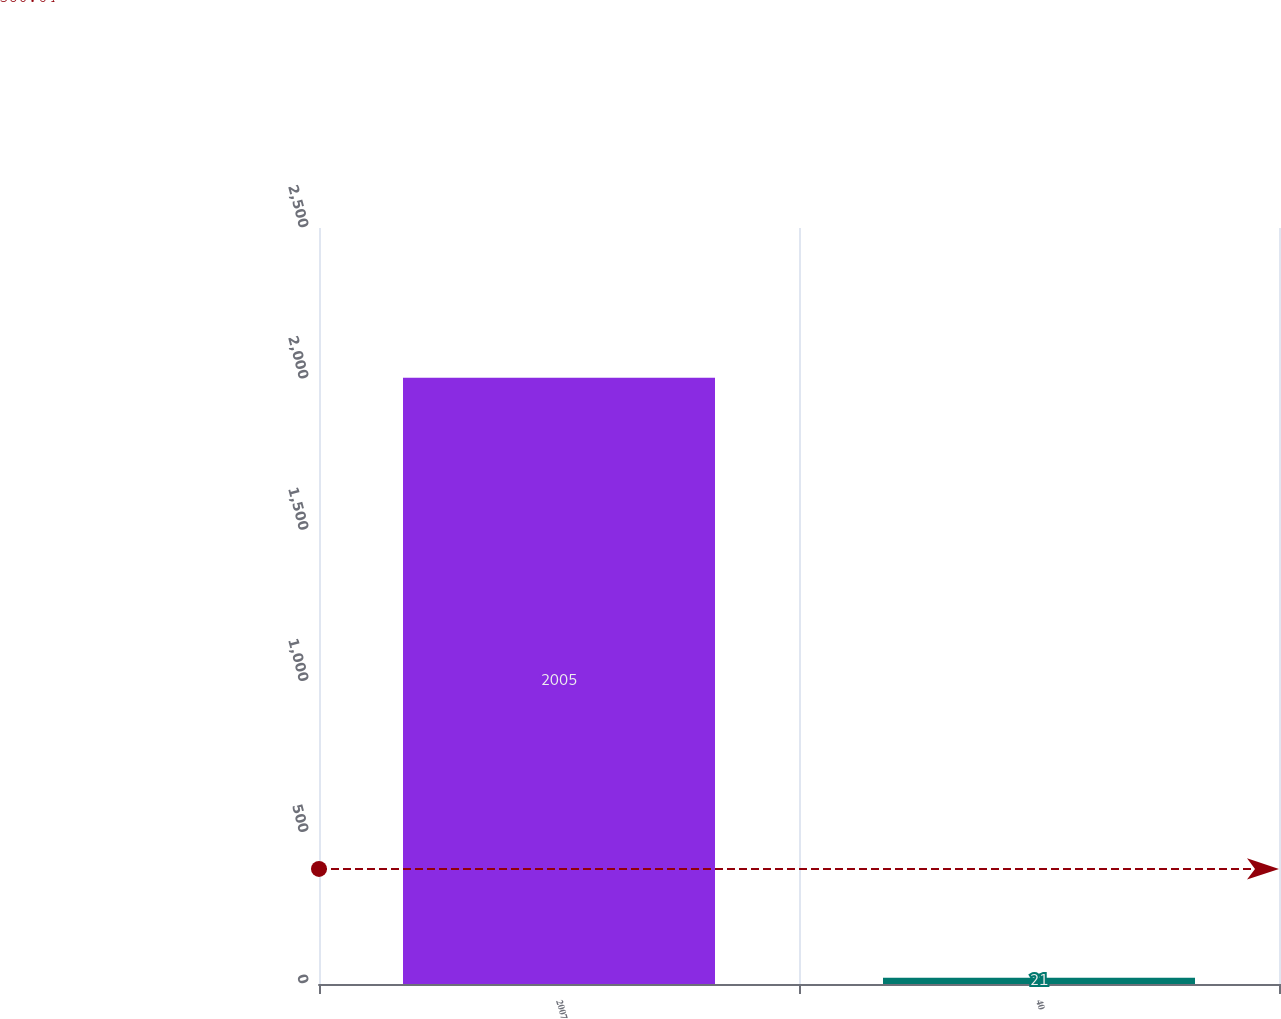Convert chart to OTSL. <chart><loc_0><loc_0><loc_500><loc_500><bar_chart><fcel>2007<fcel>40<nl><fcel>2005<fcel>21<nl></chart> 